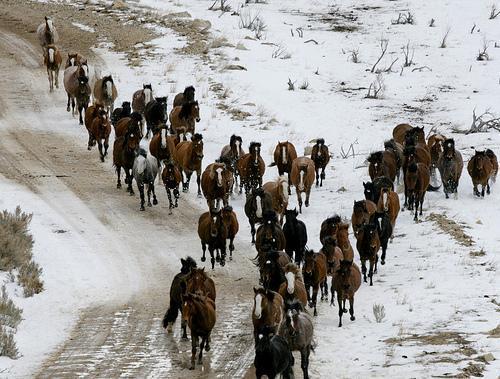How many black horses are in the image?
Give a very brief answer. 1. 